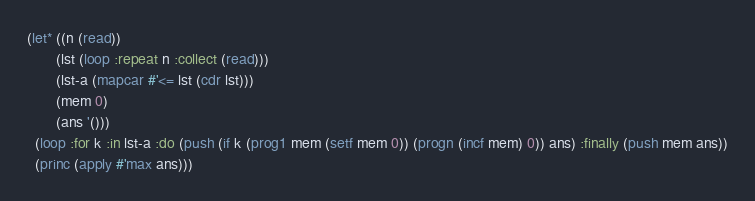<code> <loc_0><loc_0><loc_500><loc_500><_Lisp_>(let* ((n (read))
       (lst (loop :repeat n :collect (read)))
       (lst-a (mapcar #'<= lst (cdr lst)))
       (mem 0)
       (ans '()))
  (loop :for k :in lst-a :do (push (if k (prog1 mem (setf mem 0)) (progn (incf mem) 0)) ans) :finally (push mem ans))
  (princ (apply #'max ans)))</code> 